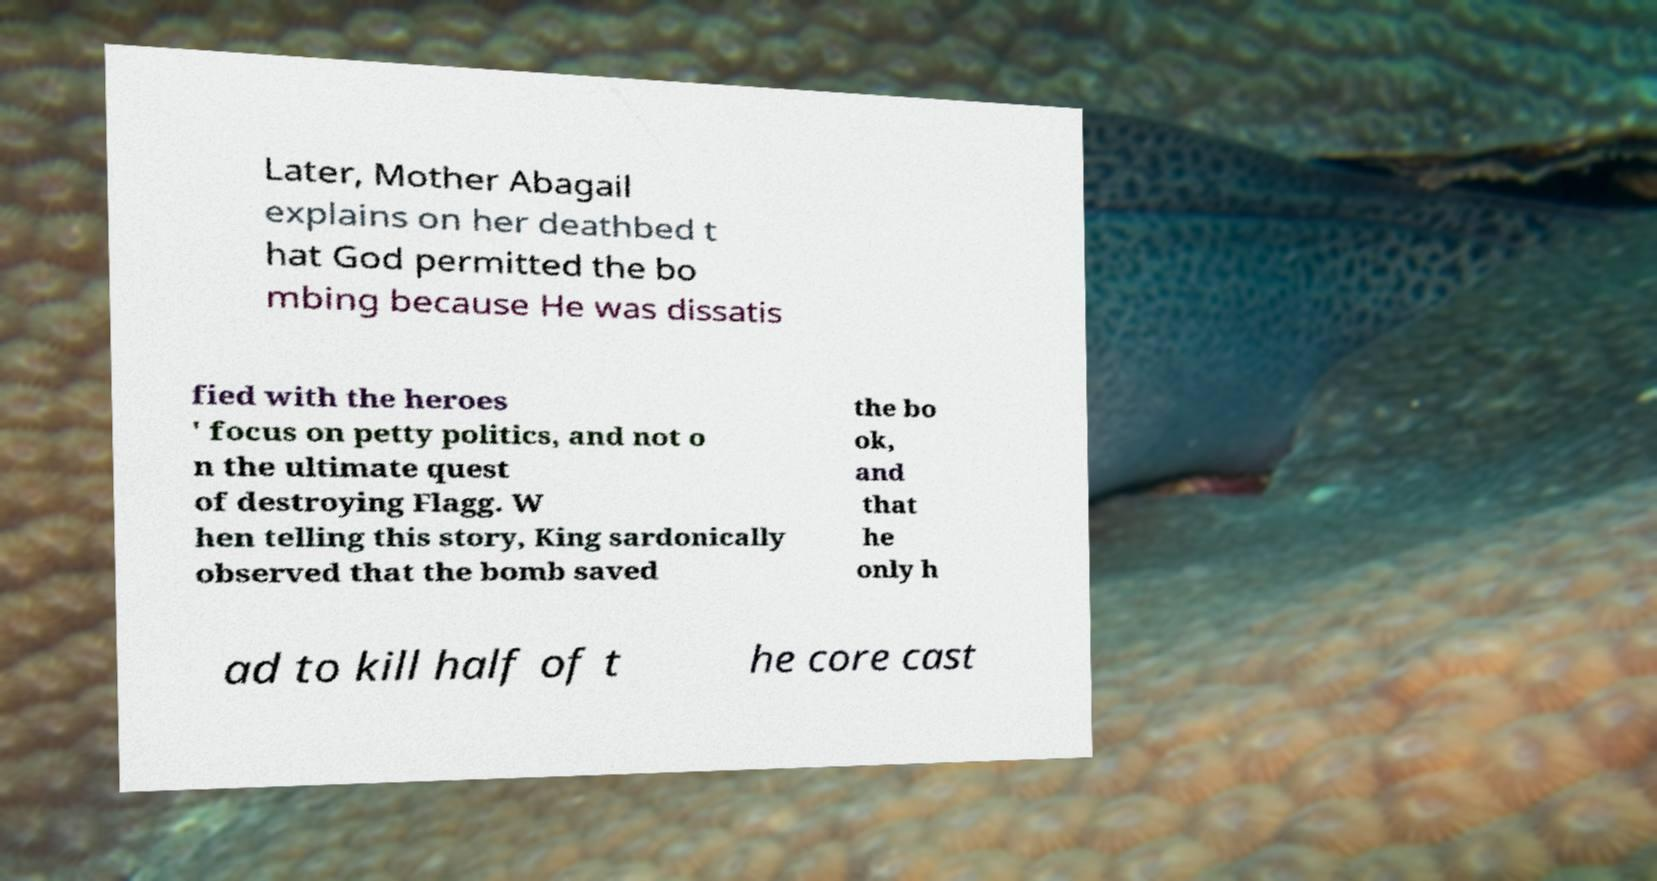I need the written content from this picture converted into text. Can you do that? Later, Mother Abagail explains on her deathbed t hat God permitted the bo mbing because He was dissatis fied with the heroes ' focus on petty politics, and not o n the ultimate quest of destroying Flagg. W hen telling this story, King sardonically observed that the bomb saved the bo ok, and that he only h ad to kill half of t he core cast 